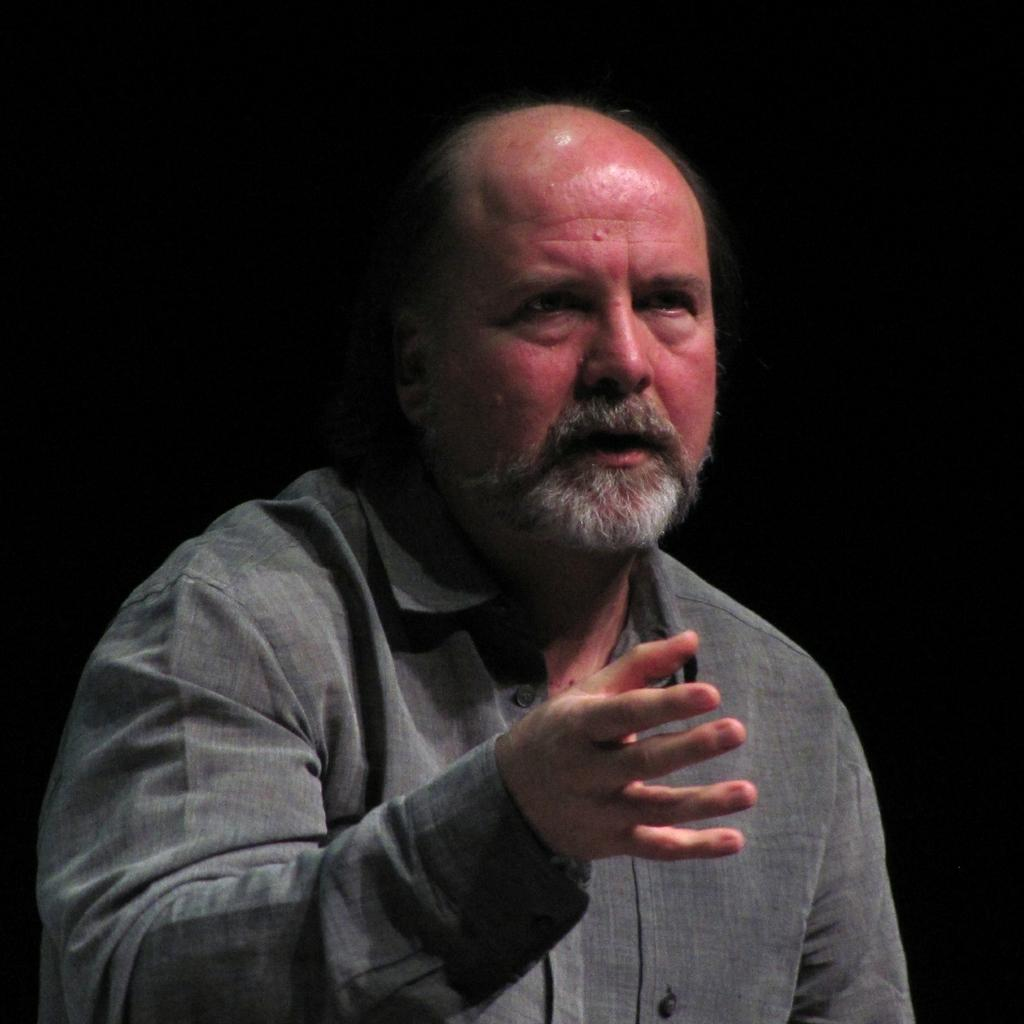Who is the main subject in the image? There is a man in the center of the image. What is the man doing in the image? The provided facts do not specify what the man is doing in the image. Can you describe the man's appearance or clothing in the image? The provided facts do not specify the man's appearance or clothing. What type of acoustics can be heard in the background of the image? There is no information about acoustics or background sounds in the provided facts, so it cannot be determined from the image. 